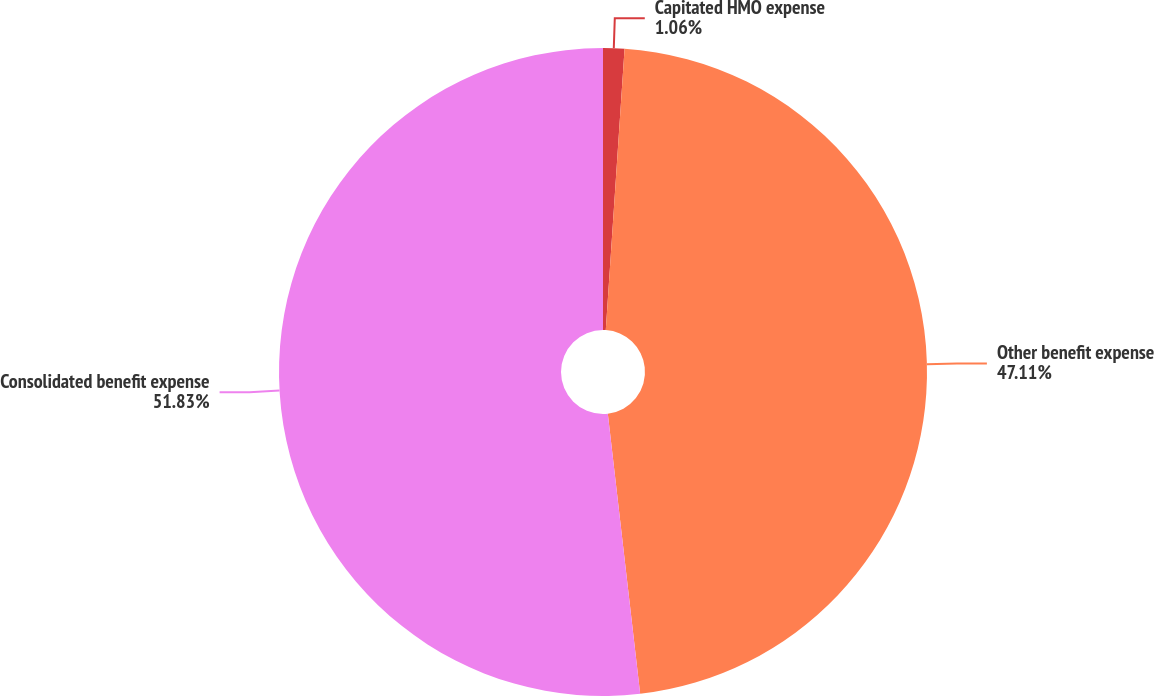<chart> <loc_0><loc_0><loc_500><loc_500><pie_chart><fcel>Capitated HMO expense<fcel>Other benefit expense<fcel>Consolidated benefit expense<nl><fcel>1.06%<fcel>47.11%<fcel>51.83%<nl></chart> 